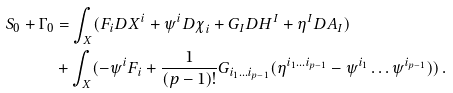Convert formula to latex. <formula><loc_0><loc_0><loc_500><loc_500>S _ { 0 } + \Gamma _ { 0 } & = \int _ { X } ( { F } _ { i } { D X } ^ { i } + { \psi } ^ { i } { D \chi } _ { i } + G _ { I } D { H } ^ { I } + { \eta } ^ { I } { D A } _ { I } ) \\ & + \int _ { X } ( - \psi ^ { i } F _ { i } + \frac { 1 } { ( p - 1 ) ! } G _ { i _ { 1 } \dots i _ { p - 1 } } ( \eta ^ { i _ { 1 } \dots i _ { p - 1 } } - \psi ^ { i _ { 1 } } \dots \psi ^ { i _ { p - 1 } } ) ) \, .</formula> 